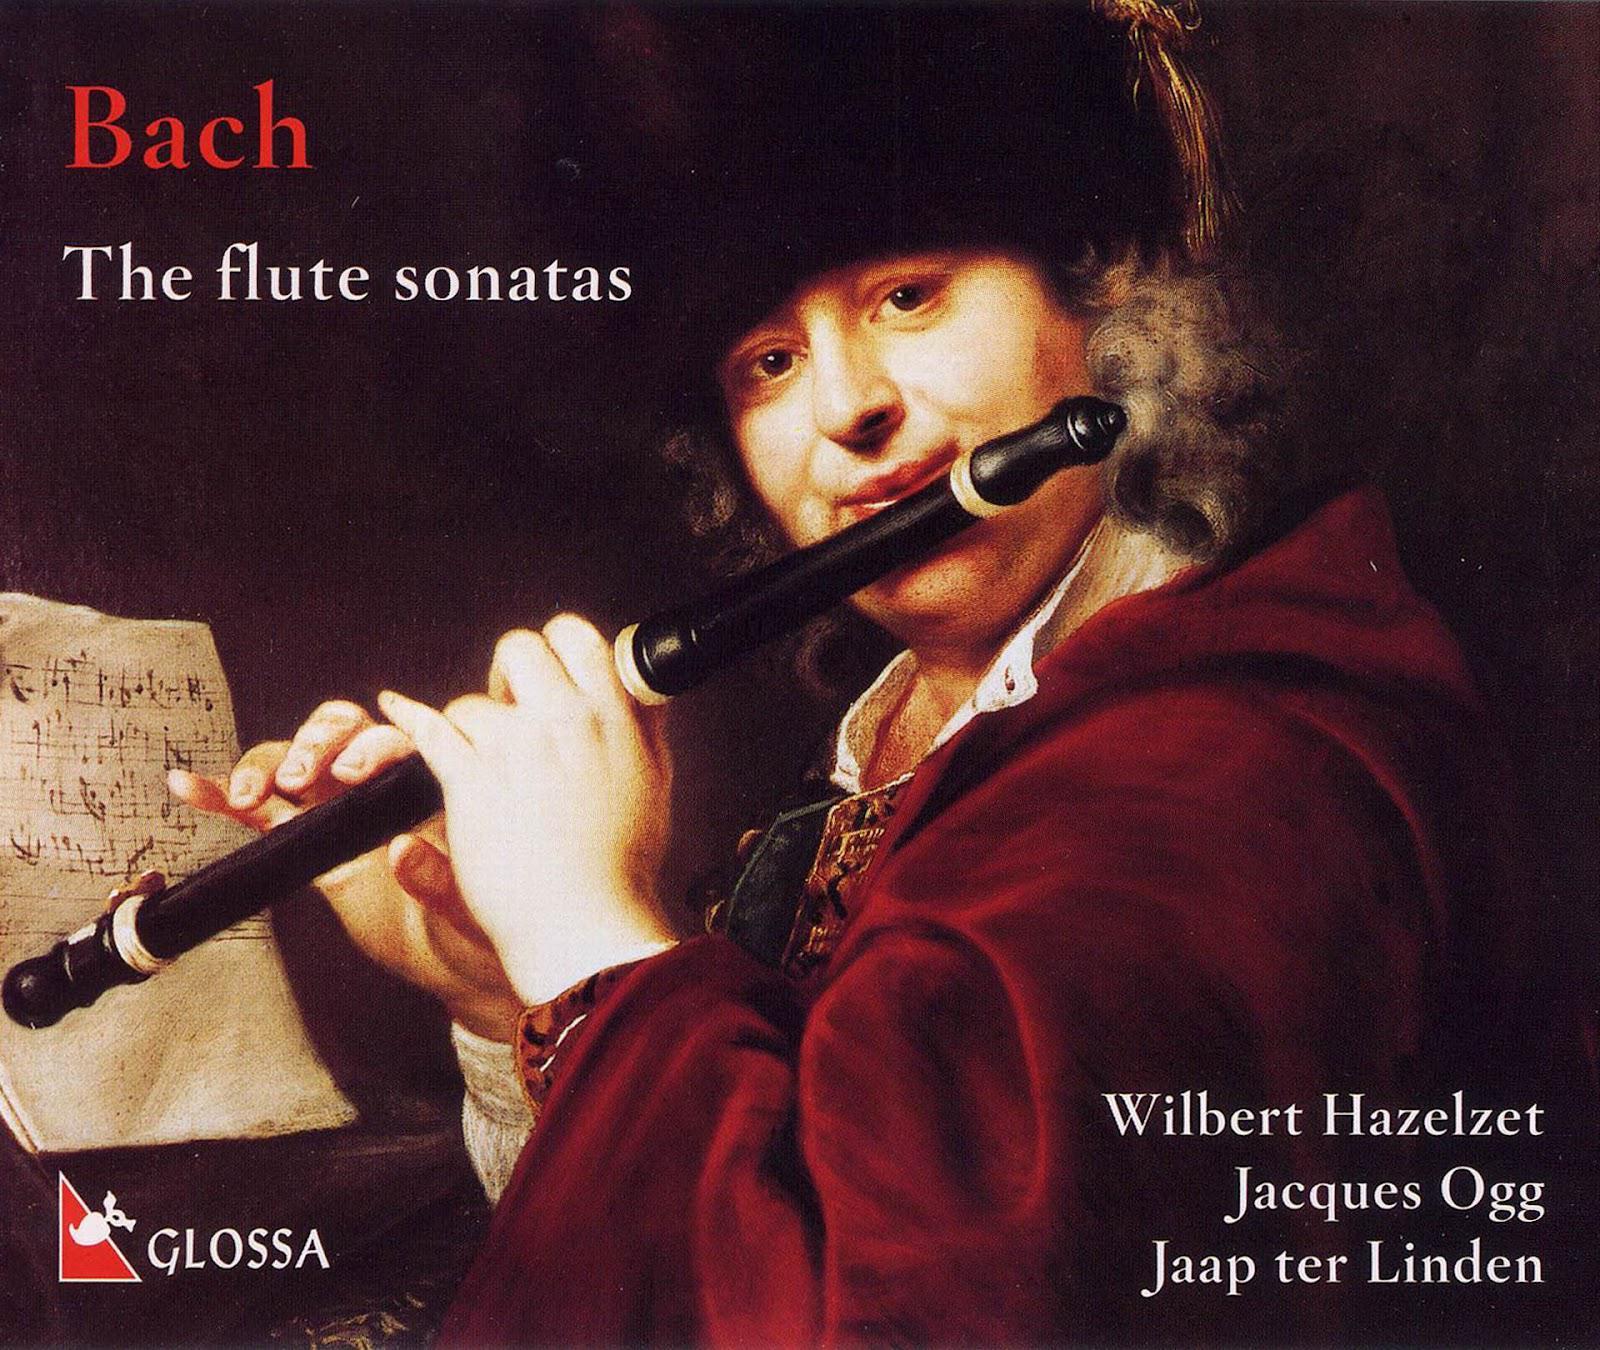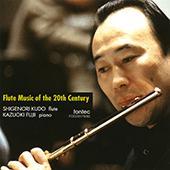The first image is the image on the left, the second image is the image on the right. Given the left and right images, does the statement "An image shows a man with a gray beard in a dark suit, holding a flute up to his ear with the hand on the left." hold true? Answer yes or no. No. The first image is the image on the left, the second image is the image on the right. Evaluate the accuracy of this statement regarding the images: "At least one musician is playing the flute.". Is it true? Answer yes or no. Yes. 